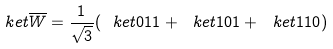<formula> <loc_0><loc_0><loc_500><loc_500>\ k e t { \overline { W } } = \frac { 1 } { \sqrt { 3 } } ( \ k e t { 0 1 1 } + \ k e t { 1 0 1 } + \ k e t { 1 1 0 } )</formula> 